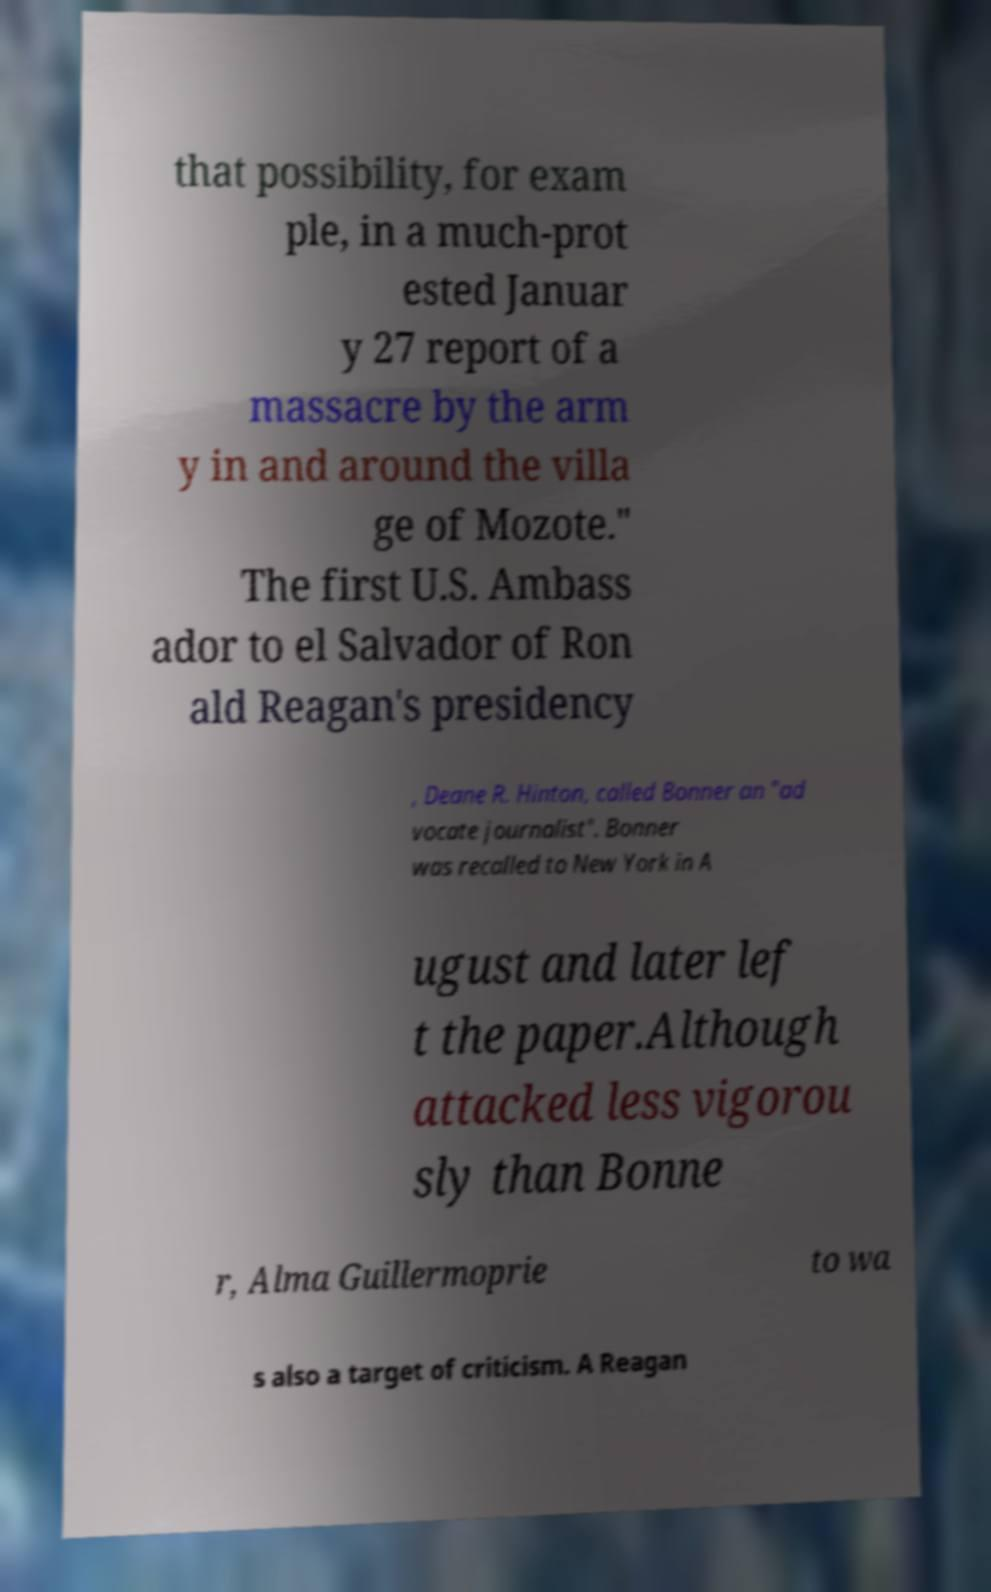There's text embedded in this image that I need extracted. Can you transcribe it verbatim? that possibility, for exam ple, in a much-prot ested Januar y 27 report of a massacre by the arm y in and around the villa ge of Mozote." The first U.S. Ambass ador to el Salvador of Ron ald Reagan's presidency , Deane R. Hinton, called Bonner an "ad vocate journalist". Bonner was recalled to New York in A ugust and later lef t the paper.Although attacked less vigorou sly than Bonne r, Alma Guillermoprie to wa s also a target of criticism. A Reagan 